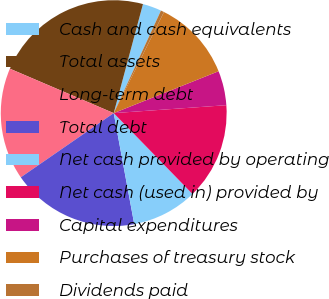Convert chart. <chart><loc_0><loc_0><loc_500><loc_500><pie_chart><fcel>Cash and cash equivalents<fcel>Total assets<fcel>Long-term debt<fcel>Total debt<fcel>Net cash provided by operating<fcel>Net cash (used in) provided by<fcel>Capital expenditures<fcel>Purchases of treasury stock<fcel>Dividends paid<nl><fcel>2.7%<fcel>22.74%<fcel>16.06%<fcel>18.29%<fcel>9.38%<fcel>13.83%<fcel>4.93%<fcel>11.61%<fcel>0.47%<nl></chart> 